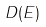Convert formula to latex. <formula><loc_0><loc_0><loc_500><loc_500>D ( E )</formula> 